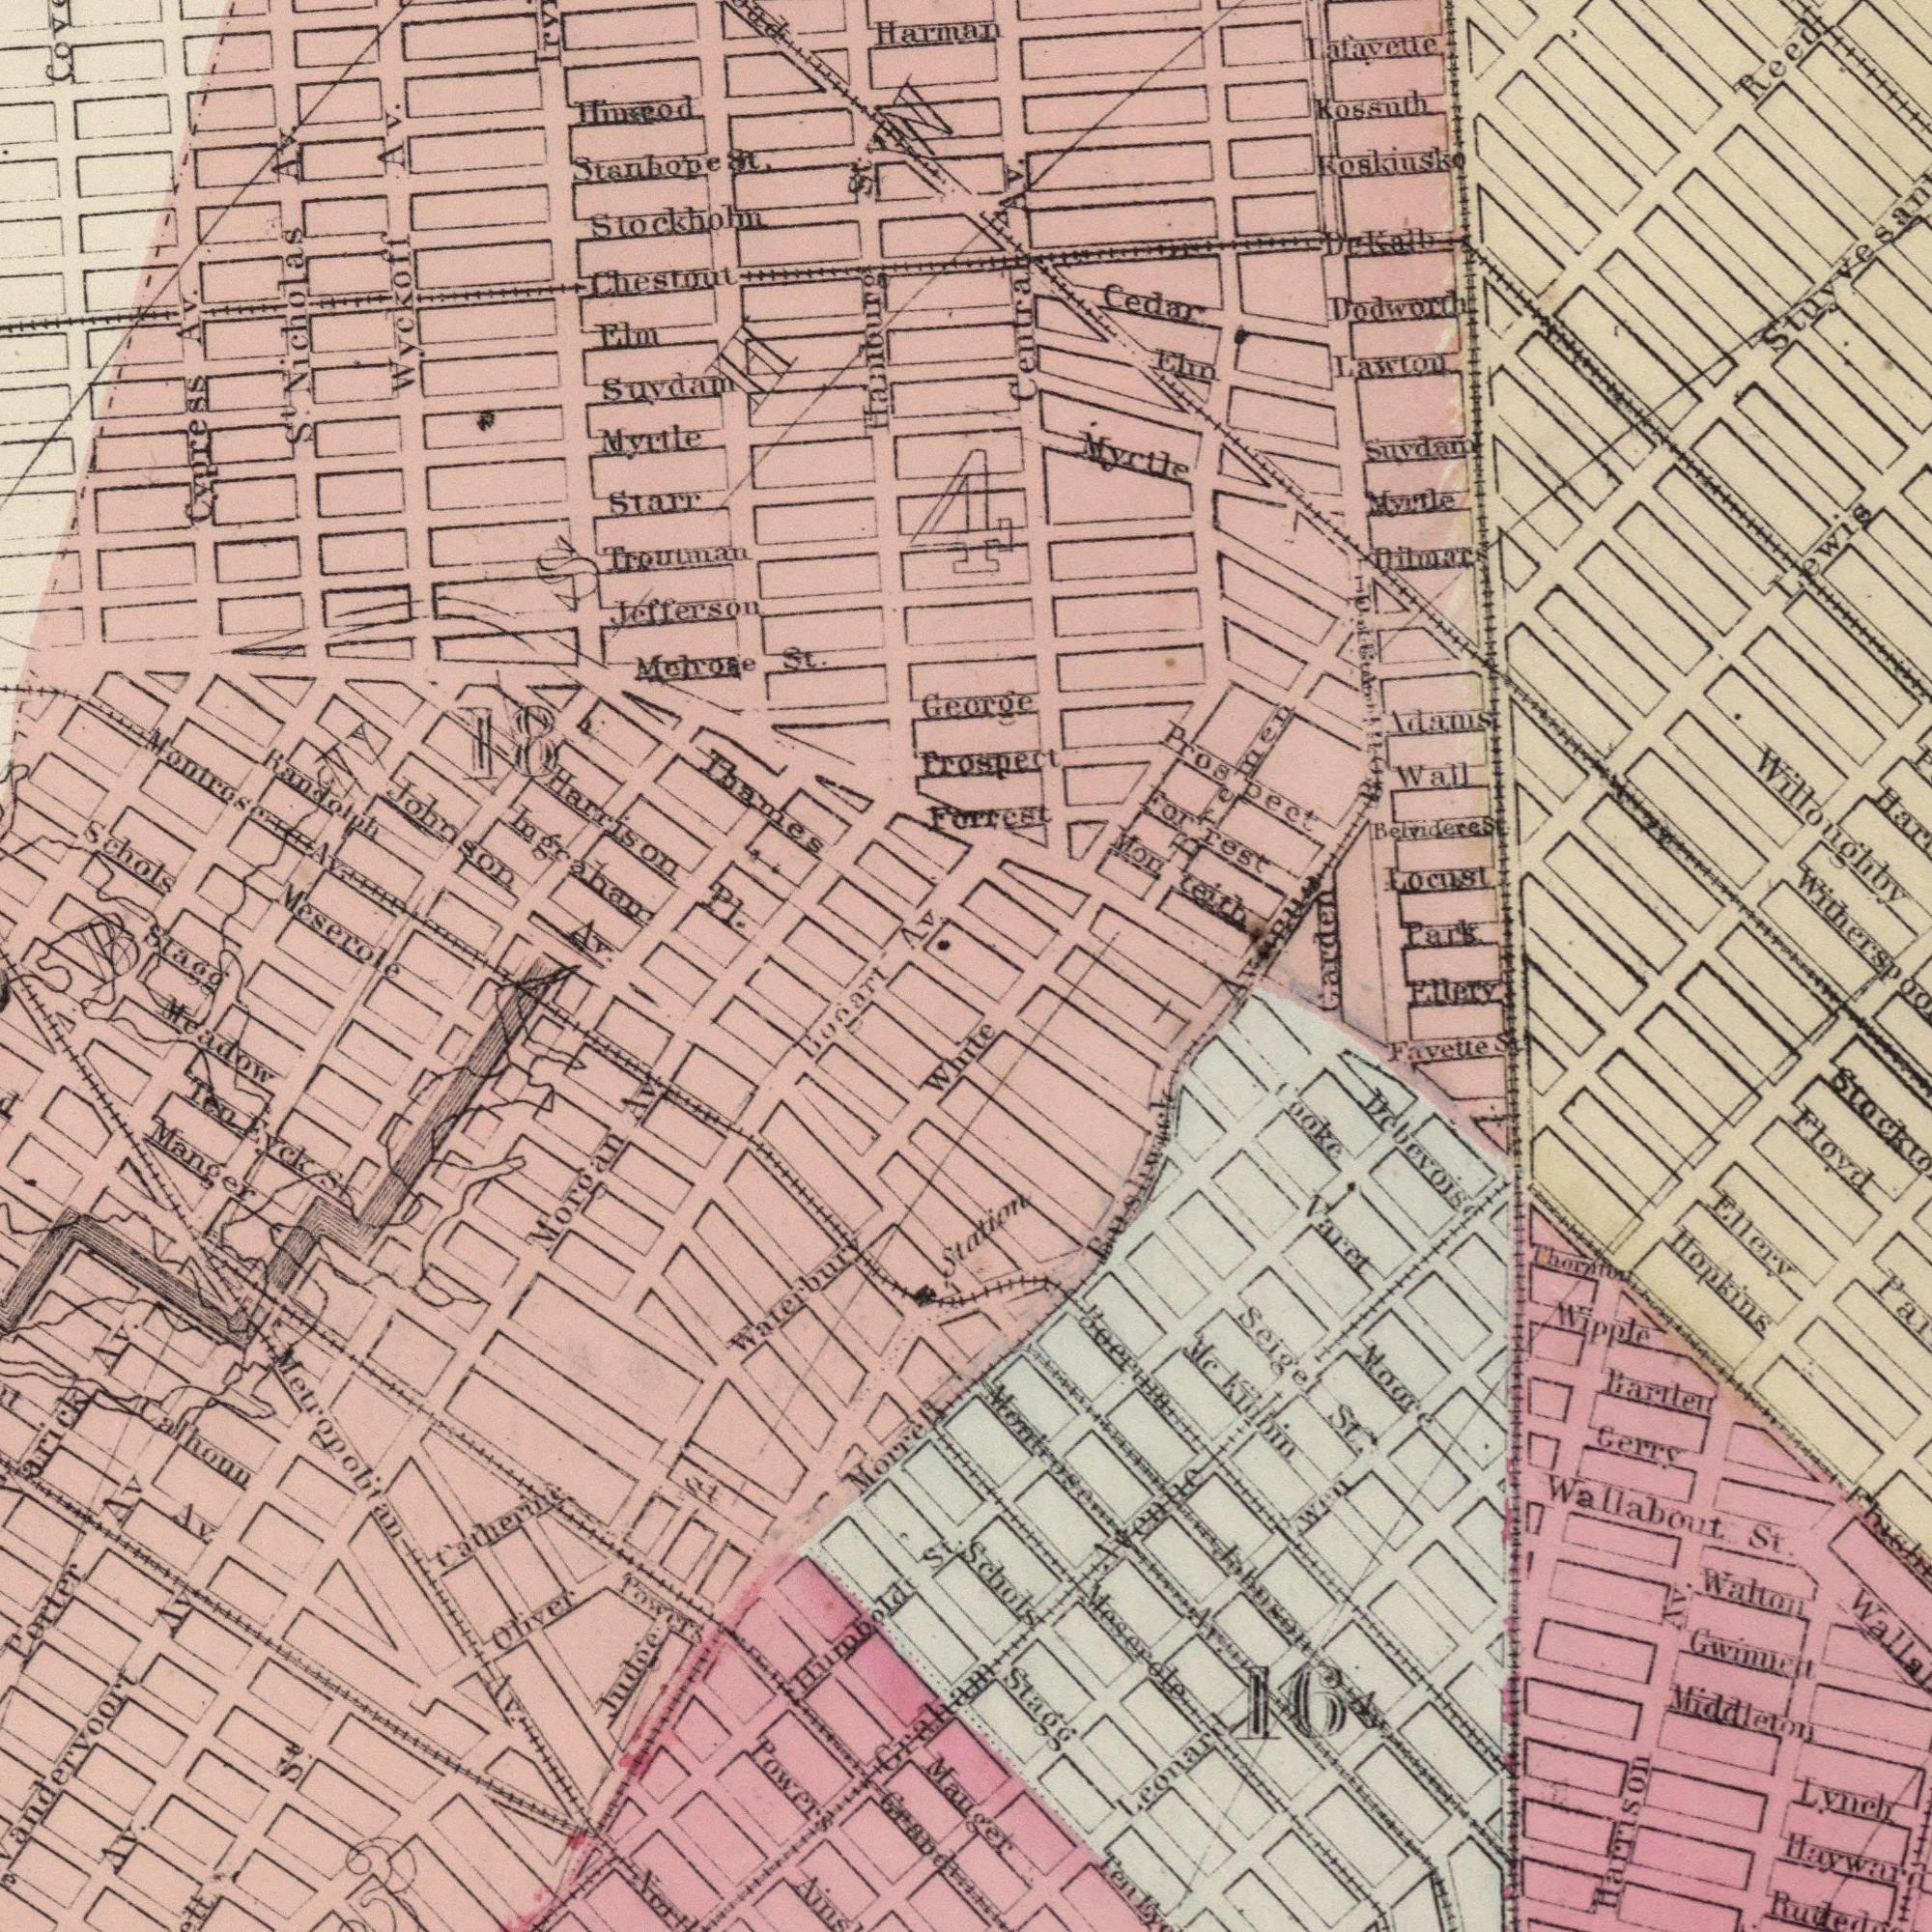What text can you see in the bottom-right section? Hopkins Gwinnet Ellery Meserole Middleton Mc Kibbin Floyd Wallabout St. Walton Cooke Varet Bartlett Stagg Montrose Av Fayette St. Moore Leonard Lynch Seige St. Schols Ellery Debevoise Wipple Thornton Gerry Boerum Harrison Av. 16 Wen Avenue Station Mauger Ten Johnson Av. What text can you see in the top-right section? Koskiusko Locust Myrtle Lafayette Cedar Kossuth Lawton Myrtle Park Wall Elin Centra Av. Suydam Reed Dodworth Forrest Prospect Dilmar Dekalb Adam St. George Prospect Forrest Monteith Bremen Lewis Willoughby Garden Belvidere St. Avenue What text appears in the bottom-left area of the image? Bogart Grand Porter Av Manger St Oliver Judge Humboldt St. Towers Av. Morrell Calhoun Headow Metropolitan Av. Catherine Av. Morgan Av. Ten Eyck St. Av. Av. Powers Waterbury Graham S<sup>t</sup>. 3 White What text is shown in the top-left quadrant? Randolph Meserole Troutman Wyckoff Av. Starr Myrtle Melrose St. Hinscod Stockhohn Johnson Av. Hamburg St. Elm Harman Thames Jefferson Montrose Av. Stanhope St. Chestout Suydam Schols S<sup>t</sup>. Nicholas Av. Cypress Av. Harrison PI. Av. Ingraham 4 18 Stagg 